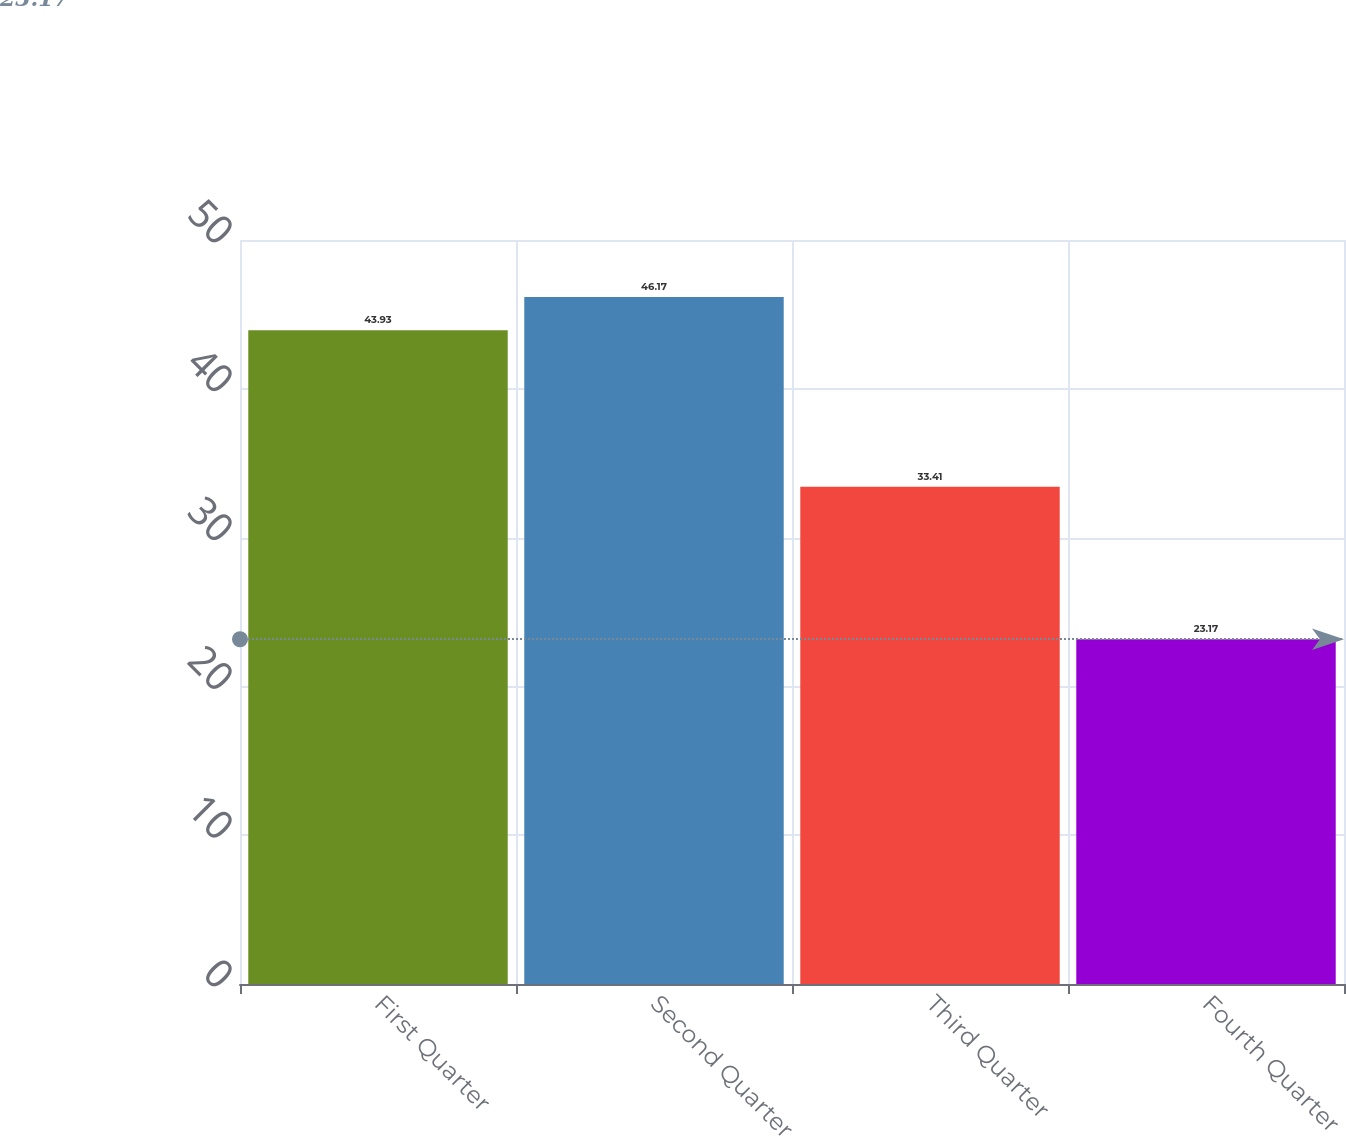Convert chart to OTSL. <chart><loc_0><loc_0><loc_500><loc_500><bar_chart><fcel>First Quarter<fcel>Second Quarter<fcel>Third Quarter<fcel>Fourth Quarter<nl><fcel>43.93<fcel>46.17<fcel>33.41<fcel>23.17<nl></chart> 